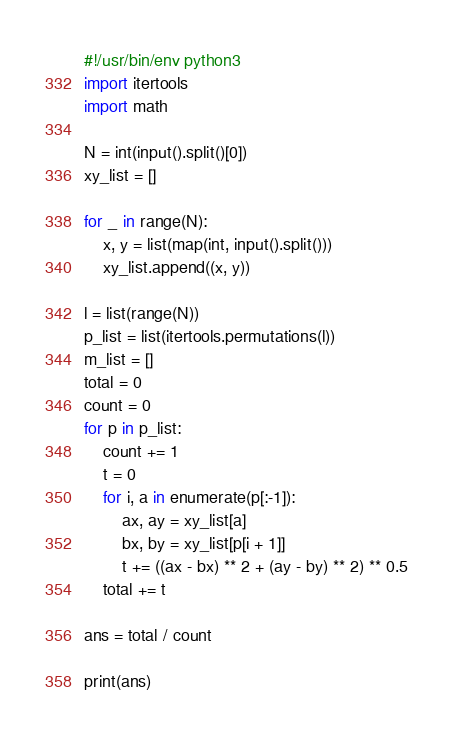Convert code to text. <code><loc_0><loc_0><loc_500><loc_500><_Python_>#!/usr/bin/env python3
import itertools
import math

N = int(input().split()[0])
xy_list = []

for _ in range(N):
    x, y = list(map(int, input().split()))
    xy_list.append((x, y))

l = list(range(N))
p_list = list(itertools.permutations(l))
m_list = []
total = 0
count = 0
for p in p_list:
    count += 1
    t = 0
    for i, a in enumerate(p[:-1]):
        ax, ay = xy_list[a]
        bx, by = xy_list[p[i + 1]]
        t += ((ax - bx) ** 2 + (ay - by) ** 2) ** 0.5
    total += t

ans = total / count

print(ans)
</code> 